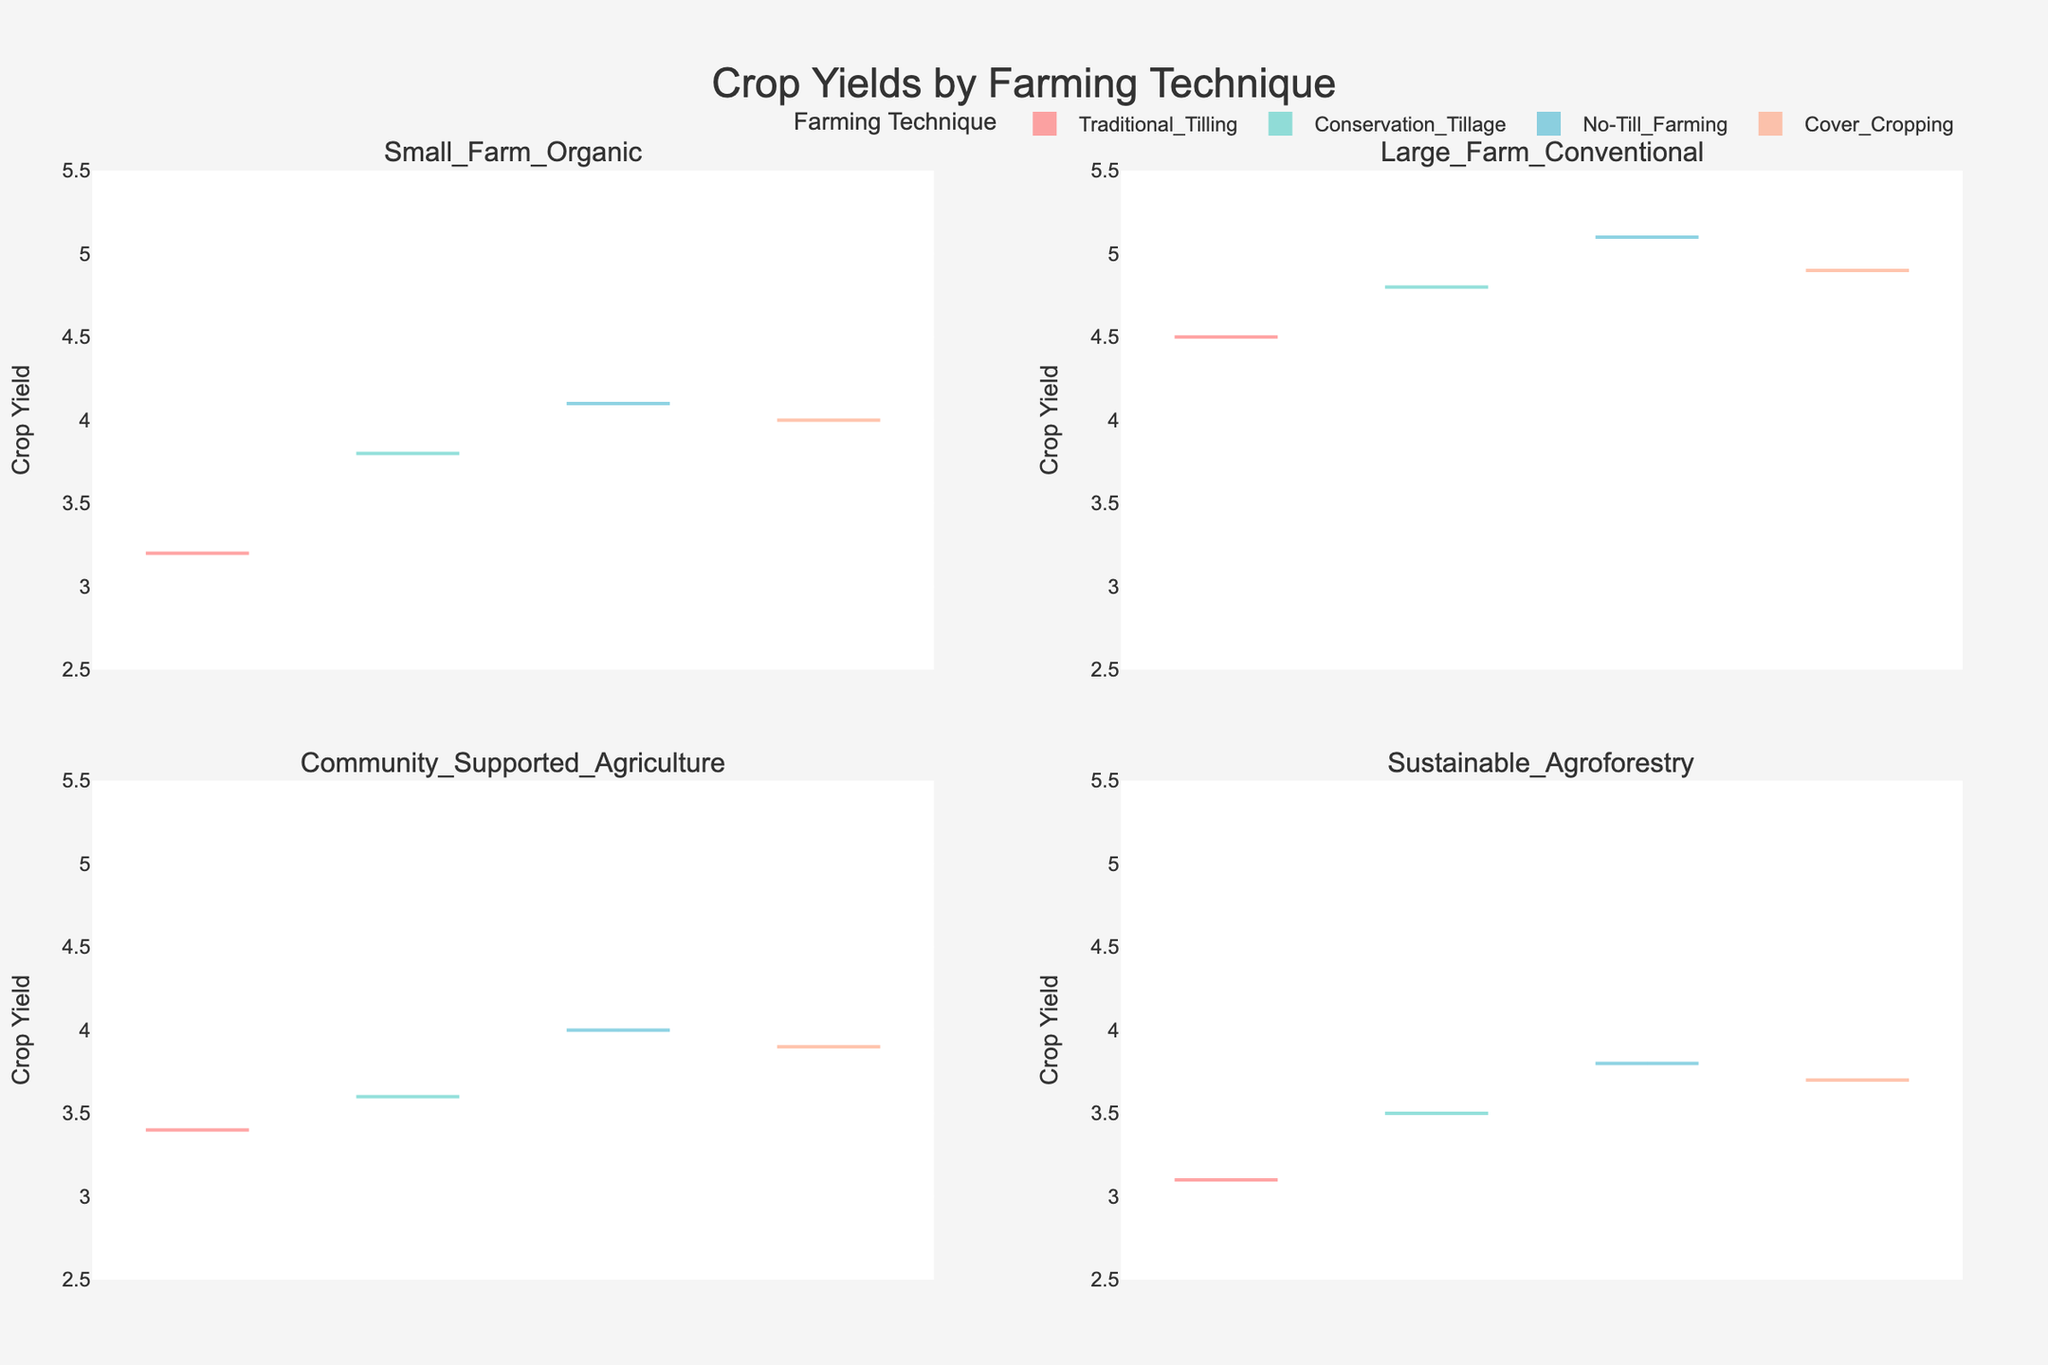What is the range of crop yield values shown in the figure? The y-axis of the violin plots indicates that crop yield values range from 2.5 to 5.5.
Answer: 2.5 to 5.5 Which farming technique shows the highest average crop yield in the Large Farm Conventional category? In the Large Farm Conventional subplot, the No-Till Farming technique's violin plot appears to have the highest average crop yield, as indicated by the mean line towards the top of the violin plot.
Answer: No-Till Farming How does the crop yield of Traditional Tilling in Small Farm Organic compare to Community Supported Agriculture? Comparing the violin plots in the Small Farm Organic and Community Supported Agriculture subplots, Traditional Tilling in Community Supported Agriculture shows a slightly higher yield on average than in Small Farm Organic.
Answer: Community Supported Agriculture has a higher yield Which farming type has the lowest maximum crop yield for No-Till Farming? By comparing the top of the No-Till Farming violin plots across all subplots, Sustainable Agroforestry has the lowest maximum crop yield.
Answer: Sustainable Agroforestry For which farming type does Conservation Tillage show a higher crop yield compared to Cover Cropping? In the Large Farm Conventional subplot, Conservation Tillage shows a slightly higher crop yield compared to Cover Cropping as indicated by the top of the violin plots.
Answer: Large Farm Conventional How do the crop yields for Cover Cropping compare between Small Farm Organic and Community Supported Agriculture? The cover Cropping violin plots in both Small Farm Organic and Community Supported Agriculture categories show similar crop yields, with the mean lines also quite close to each other, indicating comparable yields.
Answer: Similar Which farming type exhibits the most consistent crop yield for Conservation Tillage? The width of the violin plots indicates consistency. The Sustainable Agroforestry subplot shows a narrower violin plot for Conservation Tillage, implying more consistent crop yields.
Answer: Sustainable Agroforestry What can be inferred about the crop yield variation in Large Farm Conventional for Traditional Tilling? The violin plot for Traditional Tilling in Large Farm Conventional is relatively wider compared to other techniques, suggesting a higher variation in crop yields.
Answer: High variation Comparing No-Till Farming and Cover Cropping, which technique yields more in Sustainable Agroforestry? The mean line in the No-Till Farming violin plot is positioned higher than in the Cover Cropping violin plot in Sustainable Agroforestry, indicating higher yields for No-Till Farming.
Answer: No-Till Farming Which farming technique shows the least crop yield improvement in Community Supported Agriculture compared to other techniques? The violin plot for Traditional Tilling in Community Supported Agriculture is lower and shows less improvement compared to other techniques which have higher mean lines.
Answer: Traditional Tilling 